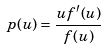Convert formula to latex. <formula><loc_0><loc_0><loc_500><loc_500>p ( u ) = \frac { u f ^ { \prime } ( u ) } { f ( u ) }</formula> 